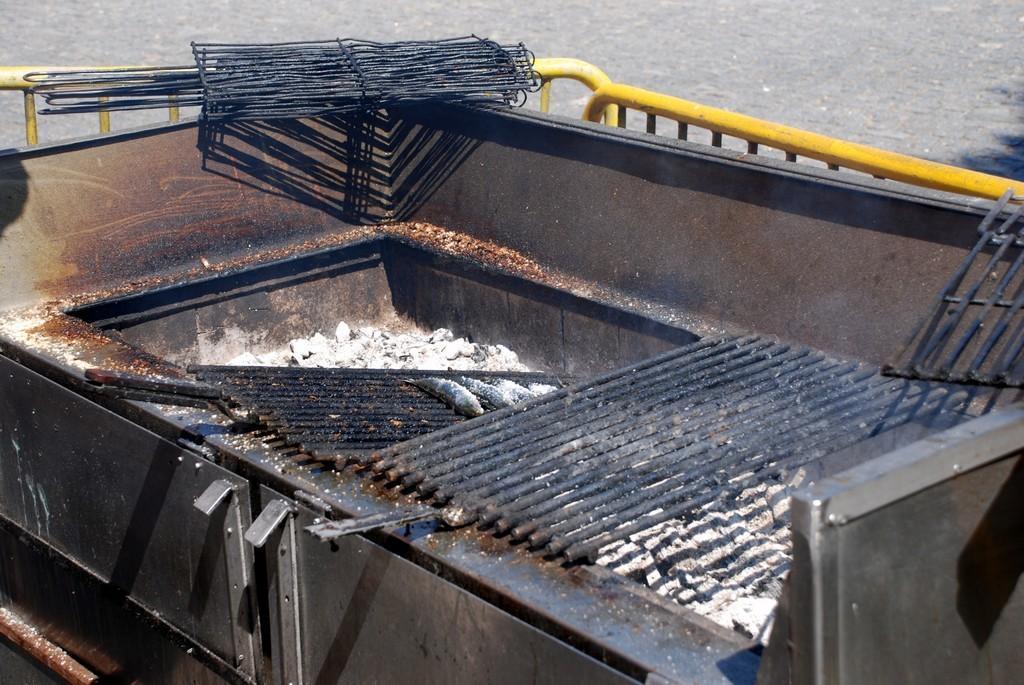Can you describe this image briefly? In this image we can see a outdoor grill rack. In the background there are grilles and we can see a road. 